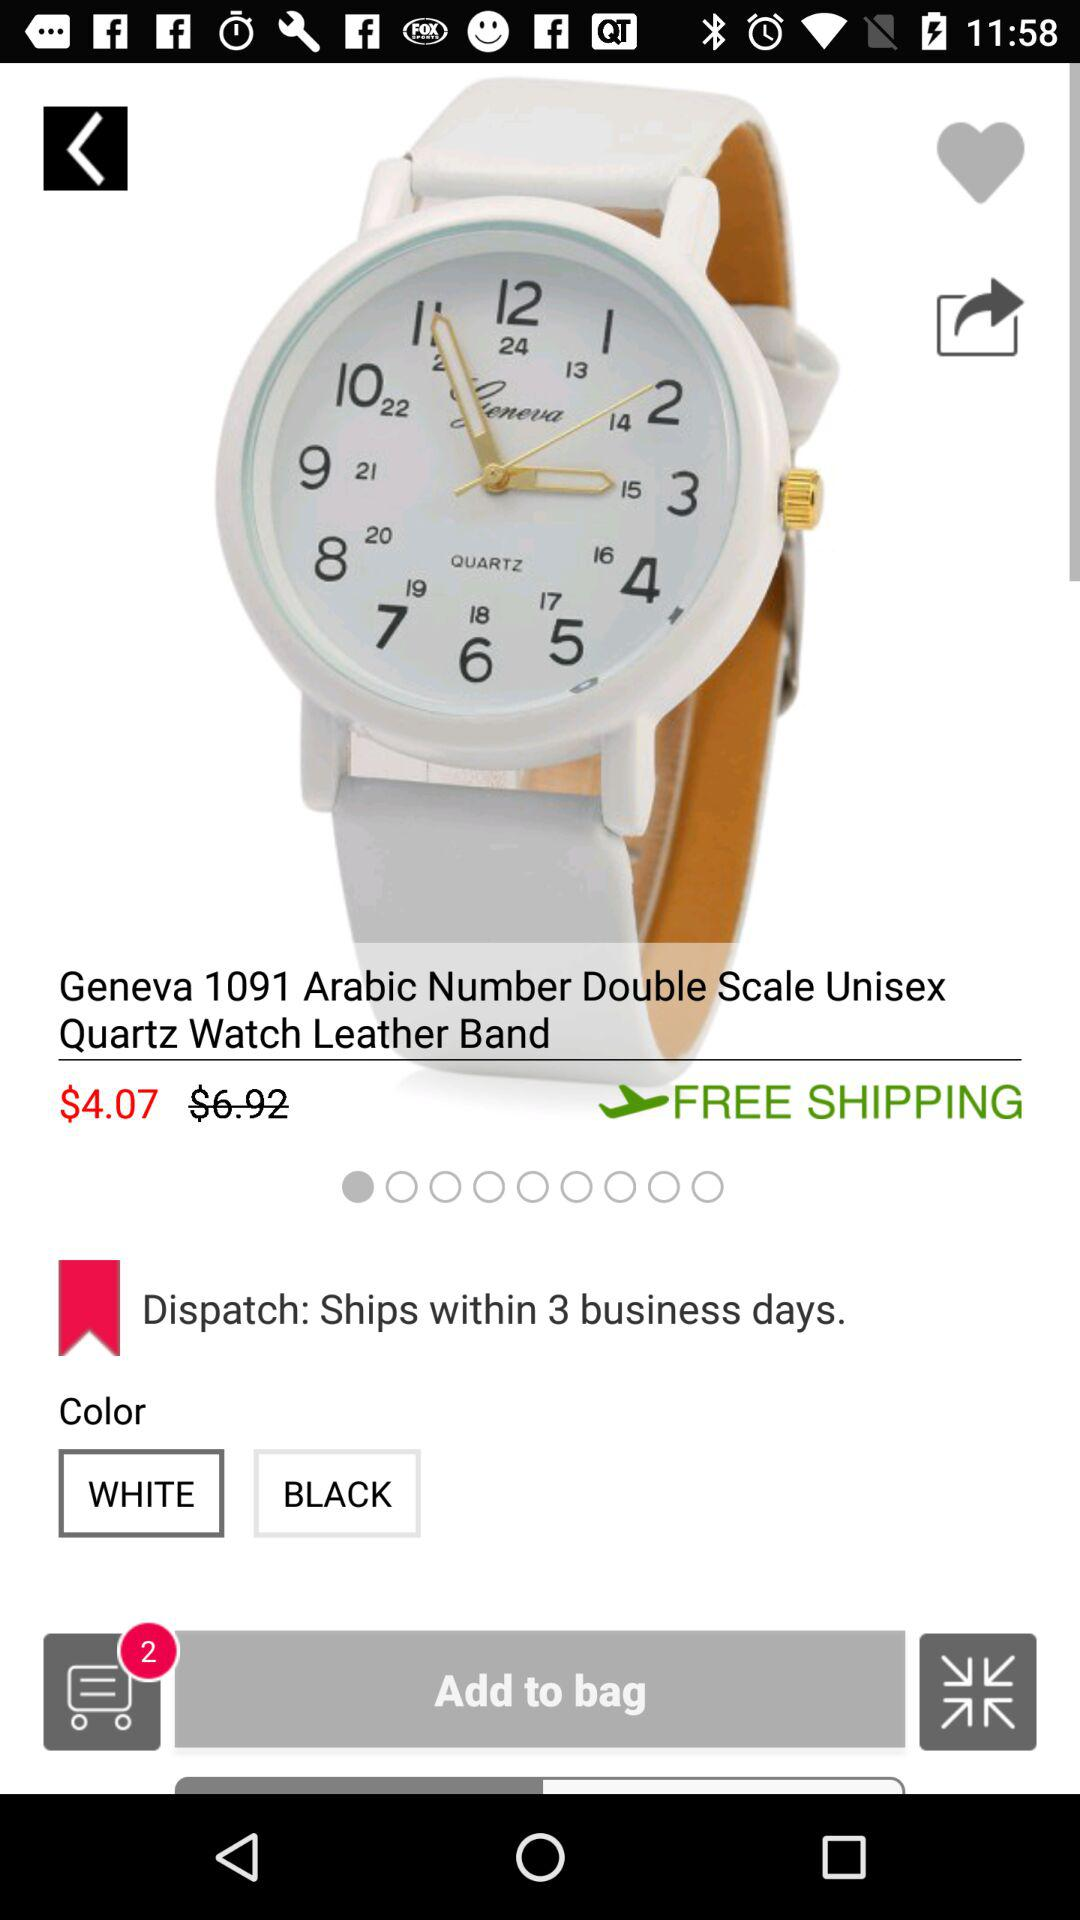What is the discounted price of the watch? The discounted price of the watch is $4.07. 